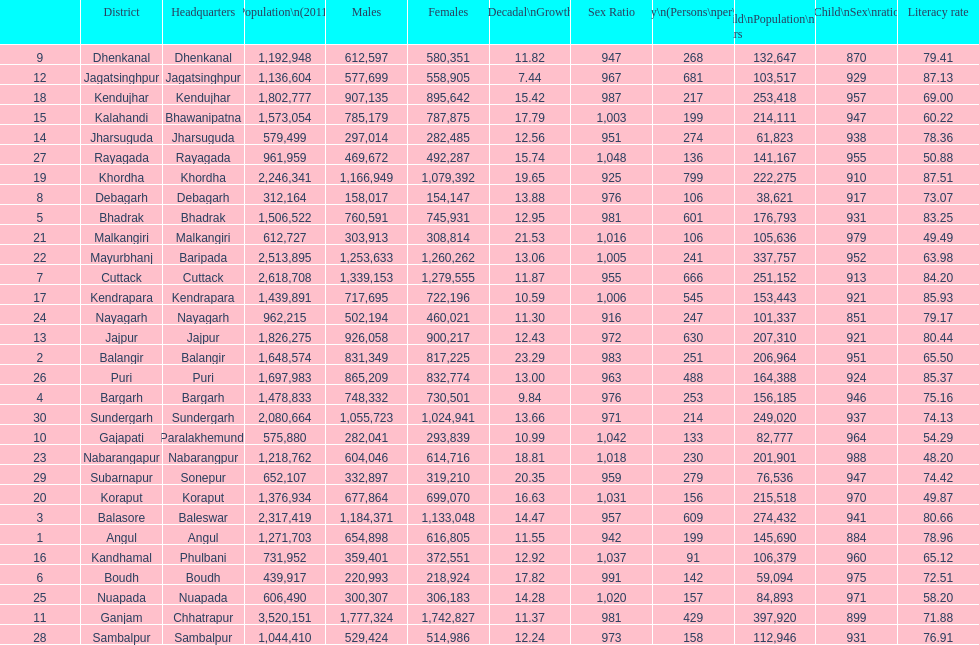Which district had least population growth from 2001-2011? Jagatsinghpur. 